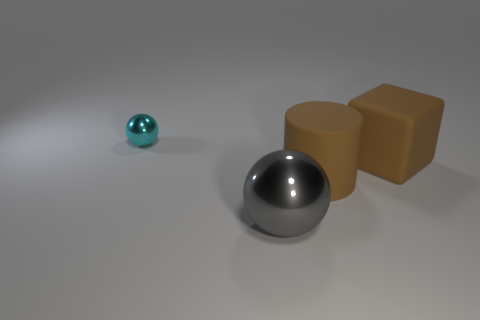What size is the shiny object that is right of the tiny cyan thing on the left side of the big gray thing?
Offer a very short reply. Large. There is a ball behind the ball that is in front of the metallic ball that is behind the rubber cylinder; what is its color?
Keep it short and to the point. Cyan. There is a thing that is both in front of the cube and behind the large gray thing; what is its size?
Offer a terse response. Large. How many other things are the same shape as the gray thing?
Your answer should be very brief. 1. What number of balls are gray shiny objects or big brown rubber objects?
Provide a succinct answer. 1. Is there a object to the right of the metallic ball in front of the big thing that is behind the big rubber cylinder?
Give a very brief answer. Yes. There is another thing that is the same shape as the small metal object; what is its color?
Provide a succinct answer. Gray. How many brown objects are cylinders or small balls?
Ensure brevity in your answer.  1. There is a ball in front of the metallic sphere that is behind the big gray metallic ball; what is its material?
Provide a short and direct response. Metal. Do the cyan object and the big gray object have the same shape?
Make the answer very short. Yes. 